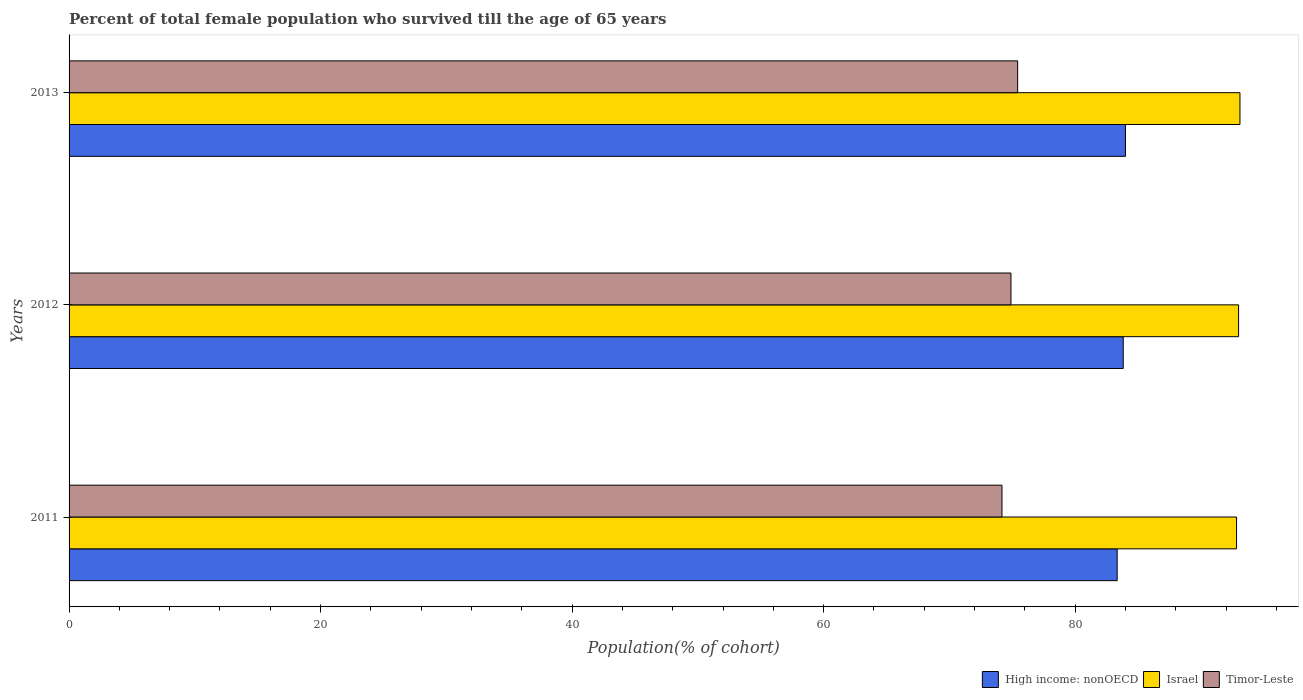How many different coloured bars are there?
Keep it short and to the point. 3. Are the number of bars per tick equal to the number of legend labels?
Your answer should be very brief. Yes. How many bars are there on the 2nd tick from the top?
Your answer should be compact. 3. How many bars are there on the 2nd tick from the bottom?
Provide a succinct answer. 3. What is the label of the 3rd group of bars from the top?
Offer a very short reply. 2011. In how many cases, is the number of bars for a given year not equal to the number of legend labels?
Your answer should be compact. 0. What is the percentage of total female population who survived till the age of 65 years in Israel in 2012?
Make the answer very short. 93. Across all years, what is the maximum percentage of total female population who survived till the age of 65 years in High income: nonOECD?
Your answer should be compact. 84. Across all years, what is the minimum percentage of total female population who survived till the age of 65 years in High income: nonOECD?
Your answer should be very brief. 83.34. In which year was the percentage of total female population who survived till the age of 65 years in Timor-Leste maximum?
Your response must be concise. 2013. In which year was the percentage of total female population who survived till the age of 65 years in Israel minimum?
Give a very brief answer. 2011. What is the total percentage of total female population who survived till the age of 65 years in Timor-Leste in the graph?
Give a very brief answer. 224.51. What is the difference between the percentage of total female population who survived till the age of 65 years in Timor-Leste in 2011 and that in 2012?
Provide a short and direct response. -0.72. What is the difference between the percentage of total female population who survived till the age of 65 years in Timor-Leste in 2011 and the percentage of total female population who survived till the age of 65 years in Israel in 2013?
Give a very brief answer. -18.92. What is the average percentage of total female population who survived till the age of 65 years in High income: nonOECD per year?
Offer a very short reply. 83.72. In the year 2012, what is the difference between the percentage of total female population who survived till the age of 65 years in Timor-Leste and percentage of total female population who survived till the age of 65 years in Israel?
Make the answer very short. -18.1. In how many years, is the percentage of total female population who survived till the age of 65 years in Israel greater than 52 %?
Offer a very short reply. 3. What is the ratio of the percentage of total female population who survived till the age of 65 years in High income: nonOECD in 2011 to that in 2013?
Give a very brief answer. 0.99. Is the percentage of total female population who survived till the age of 65 years in Timor-Leste in 2011 less than that in 2013?
Provide a short and direct response. Yes. Is the difference between the percentage of total female population who survived till the age of 65 years in Timor-Leste in 2012 and 2013 greater than the difference between the percentage of total female population who survived till the age of 65 years in Israel in 2012 and 2013?
Offer a very short reply. No. What is the difference between the highest and the second highest percentage of total female population who survived till the age of 65 years in Israel?
Offer a very short reply. 0.11. What is the difference between the highest and the lowest percentage of total female population who survived till the age of 65 years in High income: nonOECD?
Your response must be concise. 0.66. In how many years, is the percentage of total female population who survived till the age of 65 years in High income: nonOECD greater than the average percentage of total female population who survived till the age of 65 years in High income: nonOECD taken over all years?
Offer a terse response. 2. Is the sum of the percentage of total female population who survived till the age of 65 years in High income: nonOECD in 2011 and 2013 greater than the maximum percentage of total female population who survived till the age of 65 years in Israel across all years?
Keep it short and to the point. Yes. Is it the case that in every year, the sum of the percentage of total female population who survived till the age of 65 years in High income: nonOECD and percentage of total female population who survived till the age of 65 years in Israel is greater than the percentage of total female population who survived till the age of 65 years in Timor-Leste?
Your answer should be compact. Yes. Are all the bars in the graph horizontal?
Your response must be concise. Yes. What is the difference between two consecutive major ticks on the X-axis?
Provide a short and direct response. 20. Does the graph contain any zero values?
Your answer should be very brief. No. Where does the legend appear in the graph?
Offer a terse response. Bottom right. How many legend labels are there?
Make the answer very short. 3. How are the legend labels stacked?
Provide a short and direct response. Horizontal. What is the title of the graph?
Ensure brevity in your answer.  Percent of total female population who survived till the age of 65 years. What is the label or title of the X-axis?
Your answer should be very brief. Population(% of cohort). What is the Population(% of cohort) in High income: nonOECD in 2011?
Provide a short and direct response. 83.34. What is the Population(% of cohort) in Israel in 2011?
Provide a succinct answer. 92.84. What is the Population(% of cohort) of Timor-Leste in 2011?
Make the answer very short. 74.18. What is the Population(% of cohort) in High income: nonOECD in 2012?
Your answer should be very brief. 83.82. What is the Population(% of cohort) in Israel in 2012?
Your answer should be compact. 93. What is the Population(% of cohort) in Timor-Leste in 2012?
Provide a succinct answer. 74.9. What is the Population(% of cohort) of High income: nonOECD in 2013?
Offer a terse response. 84. What is the Population(% of cohort) in Israel in 2013?
Give a very brief answer. 93.11. What is the Population(% of cohort) of Timor-Leste in 2013?
Provide a short and direct response. 75.43. Across all years, what is the maximum Population(% of cohort) of High income: nonOECD?
Offer a very short reply. 84. Across all years, what is the maximum Population(% of cohort) in Israel?
Offer a terse response. 93.11. Across all years, what is the maximum Population(% of cohort) of Timor-Leste?
Keep it short and to the point. 75.43. Across all years, what is the minimum Population(% of cohort) of High income: nonOECD?
Offer a very short reply. 83.34. Across all years, what is the minimum Population(% of cohort) in Israel?
Keep it short and to the point. 92.84. Across all years, what is the minimum Population(% of cohort) in Timor-Leste?
Keep it short and to the point. 74.18. What is the total Population(% of cohort) of High income: nonOECD in the graph?
Offer a terse response. 251.17. What is the total Population(% of cohort) of Israel in the graph?
Provide a short and direct response. 278.94. What is the total Population(% of cohort) of Timor-Leste in the graph?
Offer a very short reply. 224.51. What is the difference between the Population(% of cohort) of High income: nonOECD in 2011 and that in 2012?
Make the answer very short. -0.48. What is the difference between the Population(% of cohort) of Israel in 2011 and that in 2012?
Your response must be concise. -0.16. What is the difference between the Population(% of cohort) of Timor-Leste in 2011 and that in 2012?
Make the answer very short. -0.72. What is the difference between the Population(% of cohort) of High income: nonOECD in 2011 and that in 2013?
Offer a terse response. -0.66. What is the difference between the Population(% of cohort) of Israel in 2011 and that in 2013?
Make the answer very short. -0.27. What is the difference between the Population(% of cohort) of Timor-Leste in 2011 and that in 2013?
Your answer should be very brief. -1.25. What is the difference between the Population(% of cohort) of High income: nonOECD in 2012 and that in 2013?
Offer a terse response. -0.18. What is the difference between the Population(% of cohort) in Israel in 2012 and that in 2013?
Your answer should be very brief. -0.11. What is the difference between the Population(% of cohort) of Timor-Leste in 2012 and that in 2013?
Keep it short and to the point. -0.53. What is the difference between the Population(% of cohort) in High income: nonOECD in 2011 and the Population(% of cohort) in Israel in 2012?
Provide a short and direct response. -9.65. What is the difference between the Population(% of cohort) in High income: nonOECD in 2011 and the Population(% of cohort) in Timor-Leste in 2012?
Offer a terse response. 8.44. What is the difference between the Population(% of cohort) of Israel in 2011 and the Population(% of cohort) of Timor-Leste in 2012?
Give a very brief answer. 17.94. What is the difference between the Population(% of cohort) in High income: nonOECD in 2011 and the Population(% of cohort) in Israel in 2013?
Offer a terse response. -9.76. What is the difference between the Population(% of cohort) in High income: nonOECD in 2011 and the Population(% of cohort) in Timor-Leste in 2013?
Make the answer very short. 7.91. What is the difference between the Population(% of cohort) in Israel in 2011 and the Population(% of cohort) in Timor-Leste in 2013?
Your response must be concise. 17.41. What is the difference between the Population(% of cohort) in High income: nonOECD in 2012 and the Population(% of cohort) in Israel in 2013?
Your response must be concise. -9.28. What is the difference between the Population(% of cohort) of High income: nonOECD in 2012 and the Population(% of cohort) of Timor-Leste in 2013?
Your answer should be compact. 8.39. What is the difference between the Population(% of cohort) in Israel in 2012 and the Population(% of cohort) in Timor-Leste in 2013?
Ensure brevity in your answer.  17.57. What is the average Population(% of cohort) of High income: nonOECD per year?
Offer a very short reply. 83.72. What is the average Population(% of cohort) in Israel per year?
Keep it short and to the point. 92.98. What is the average Population(% of cohort) of Timor-Leste per year?
Provide a short and direct response. 74.84. In the year 2011, what is the difference between the Population(% of cohort) of High income: nonOECD and Population(% of cohort) of Israel?
Ensure brevity in your answer.  -9.49. In the year 2011, what is the difference between the Population(% of cohort) in High income: nonOECD and Population(% of cohort) in Timor-Leste?
Your answer should be compact. 9.16. In the year 2011, what is the difference between the Population(% of cohort) in Israel and Population(% of cohort) in Timor-Leste?
Ensure brevity in your answer.  18.66. In the year 2012, what is the difference between the Population(% of cohort) of High income: nonOECD and Population(% of cohort) of Israel?
Provide a succinct answer. -9.17. In the year 2012, what is the difference between the Population(% of cohort) in High income: nonOECD and Population(% of cohort) in Timor-Leste?
Your answer should be compact. 8.93. In the year 2012, what is the difference between the Population(% of cohort) of Israel and Population(% of cohort) of Timor-Leste?
Make the answer very short. 18.1. In the year 2013, what is the difference between the Population(% of cohort) of High income: nonOECD and Population(% of cohort) of Israel?
Offer a terse response. -9.1. In the year 2013, what is the difference between the Population(% of cohort) in High income: nonOECD and Population(% of cohort) in Timor-Leste?
Provide a succinct answer. 8.57. In the year 2013, what is the difference between the Population(% of cohort) of Israel and Population(% of cohort) of Timor-Leste?
Your answer should be compact. 17.68. What is the ratio of the Population(% of cohort) of Israel in 2011 to that in 2012?
Your answer should be very brief. 1. What is the ratio of the Population(% of cohort) of High income: nonOECD in 2011 to that in 2013?
Offer a very short reply. 0.99. What is the ratio of the Population(% of cohort) in Timor-Leste in 2011 to that in 2013?
Provide a succinct answer. 0.98. What is the ratio of the Population(% of cohort) of Israel in 2012 to that in 2013?
Give a very brief answer. 1. What is the ratio of the Population(% of cohort) in Timor-Leste in 2012 to that in 2013?
Offer a very short reply. 0.99. What is the difference between the highest and the second highest Population(% of cohort) in High income: nonOECD?
Provide a short and direct response. 0.18. What is the difference between the highest and the second highest Population(% of cohort) of Israel?
Provide a succinct answer. 0.11. What is the difference between the highest and the second highest Population(% of cohort) of Timor-Leste?
Provide a short and direct response. 0.53. What is the difference between the highest and the lowest Population(% of cohort) of High income: nonOECD?
Your response must be concise. 0.66. What is the difference between the highest and the lowest Population(% of cohort) in Israel?
Provide a succinct answer. 0.27. What is the difference between the highest and the lowest Population(% of cohort) in Timor-Leste?
Your answer should be compact. 1.25. 